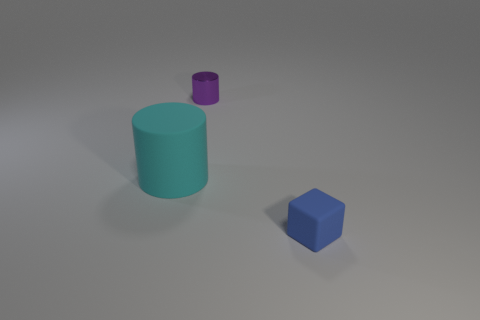Add 3 cyan rubber things. How many objects exist? 6 Subtract all purple cylinders. How many cylinders are left? 1 Subtract all cylinders. How many objects are left? 1 Subtract 1 cylinders. How many cylinders are left? 1 Subtract all gray spheres. How many gray blocks are left? 0 Subtract all purple metal objects. Subtract all tiny blue cubes. How many objects are left? 1 Add 3 blocks. How many blocks are left? 4 Add 3 tiny cylinders. How many tiny cylinders exist? 4 Subtract 0 blue spheres. How many objects are left? 3 Subtract all green cylinders. Subtract all cyan spheres. How many cylinders are left? 2 